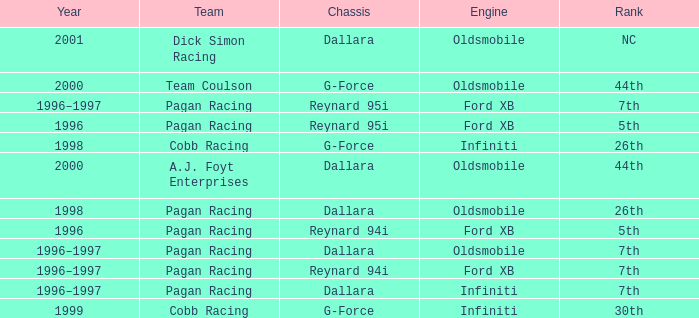What engine was used in 1999? Infiniti. 